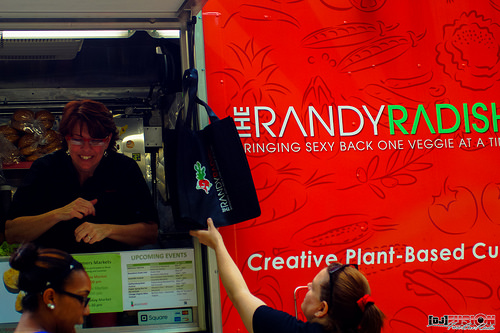<image>
Is the bag behind the banner? No. The bag is not behind the banner. From this viewpoint, the bag appears to be positioned elsewhere in the scene. 